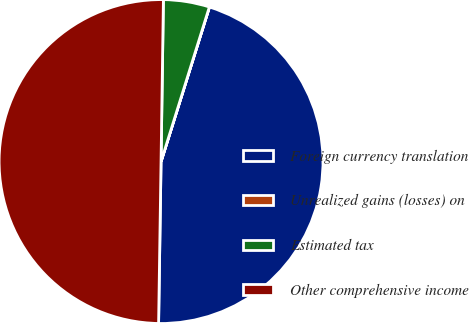Convert chart. <chart><loc_0><loc_0><loc_500><loc_500><pie_chart><fcel>Foreign currency translation<fcel>Unrealized gains (losses) on<fcel>Estimated tax<fcel>Other comprehensive income<nl><fcel>45.41%<fcel>0.01%<fcel>4.59%<fcel>49.99%<nl></chart> 